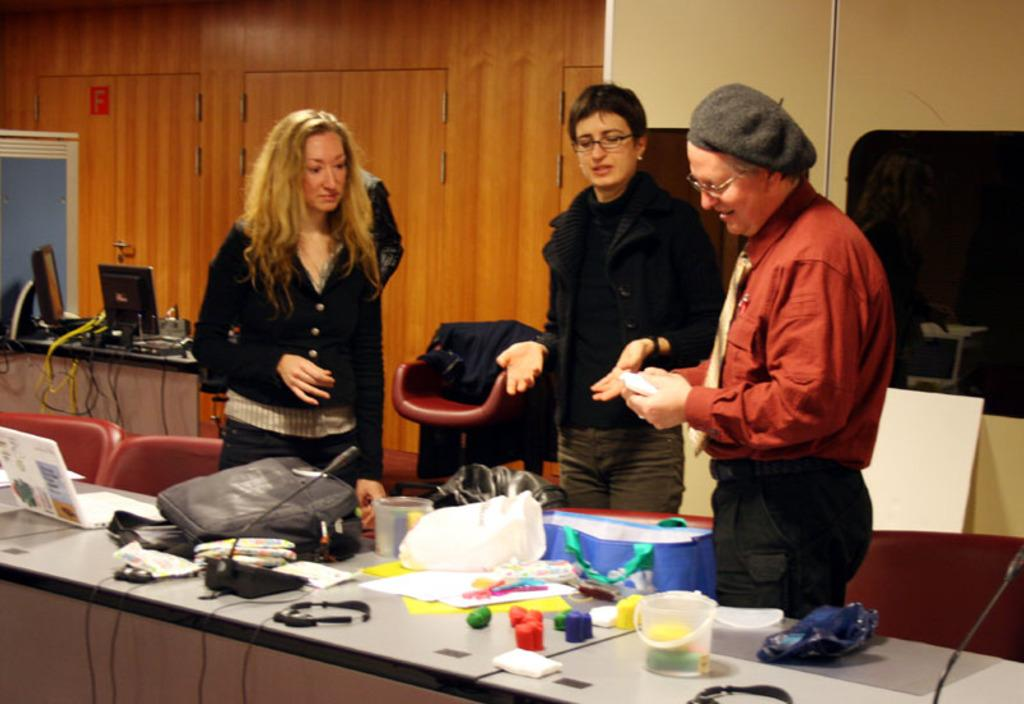What are the people doing in the image? The people are standing in front of a table. What can be seen on the table? There is a bag and a microphone (mic) on the table, along with other unspecified items. What is visible in the background of the image? There are two monitors and a wall in the background. How many trucks are parked in front of the table in the image? There are no trucks visible in the image; it only shows people standing in front of a table with a bag, a microphone, and other unspecified items. Can you tell me the color of the vase on the table? There is no vase present on the table in the image. 